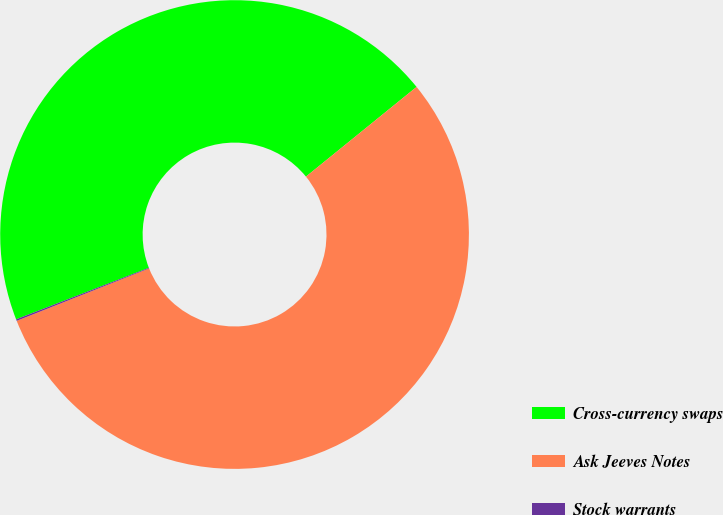Convert chart. <chart><loc_0><loc_0><loc_500><loc_500><pie_chart><fcel>Cross-currency swaps<fcel>Ask Jeeves Notes<fcel>Stock warrants<nl><fcel>45.05%<fcel>54.84%<fcel>0.11%<nl></chart> 